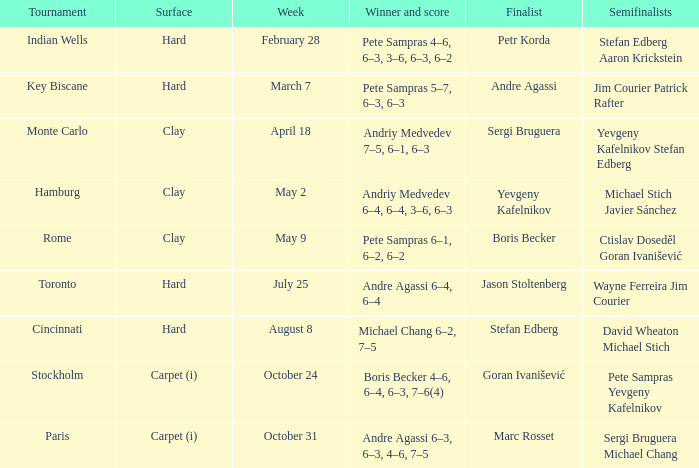Who reached the semifinals in the key biscane contest? Jim Courier Patrick Rafter. Could you parse the entire table? {'header': ['Tournament', 'Surface', 'Week', 'Winner and score', 'Finalist', 'Semifinalists'], 'rows': [['Indian Wells', 'Hard', 'February 28', 'Pete Sampras 4–6, 6–3, 3–6, 6–3, 6–2', 'Petr Korda', 'Stefan Edberg Aaron Krickstein'], ['Key Biscane', 'Hard', 'March 7', 'Pete Sampras 5–7, 6–3, 6–3', 'Andre Agassi', 'Jim Courier Patrick Rafter'], ['Monte Carlo', 'Clay', 'April 18', 'Andriy Medvedev 7–5, 6–1, 6–3', 'Sergi Bruguera', 'Yevgeny Kafelnikov Stefan Edberg'], ['Hamburg', 'Clay', 'May 2', 'Andriy Medvedev 6–4, 6–4, 3–6, 6–3', 'Yevgeny Kafelnikov', 'Michael Stich Javier Sánchez'], ['Rome', 'Clay', 'May 9', 'Pete Sampras 6–1, 6–2, 6–2', 'Boris Becker', 'Ctislav Doseděl Goran Ivanišević'], ['Toronto', 'Hard', 'July 25', 'Andre Agassi 6–4, 6–4', 'Jason Stoltenberg', 'Wayne Ferreira Jim Courier'], ['Cincinnati', 'Hard', 'August 8', 'Michael Chang 6–2, 7–5', 'Stefan Edberg', 'David Wheaton Michael Stich'], ['Stockholm', 'Carpet (i)', 'October 24', 'Boris Becker 4–6, 6–4, 6–3, 7–6(4)', 'Goran Ivanišević', 'Pete Sampras Yevgeny Kafelnikov'], ['Paris', 'Carpet (i)', 'October 31', 'Andre Agassi 6–3, 6–3, 4–6, 7–5', 'Marc Rosset', 'Sergi Bruguera Michael Chang']]} 